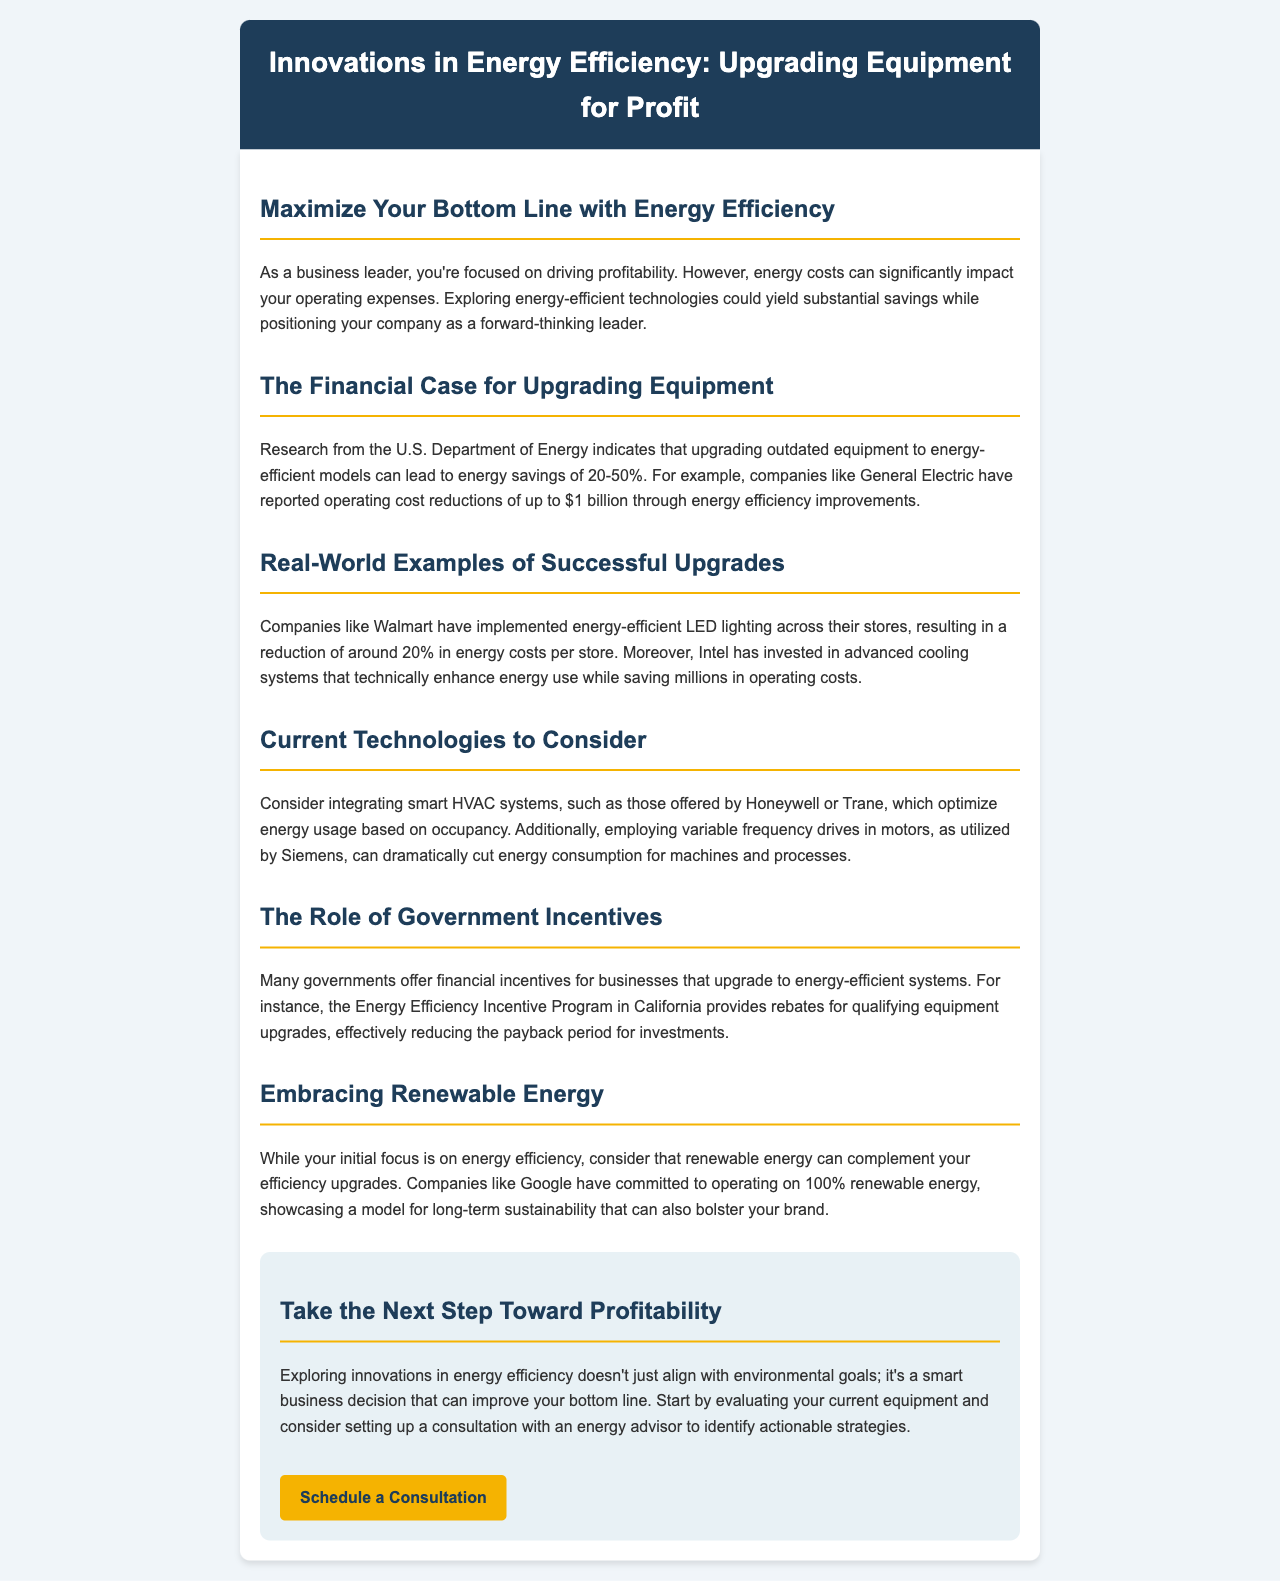What is the range of energy savings from upgrading outdated equipment? The document states that energy savings from upgrading outdated equipment can lead to savings of 20-50%.
Answer: 20-50% Which company reported operating cost reductions of up to $1 billion? The document mentions that General Electric reported these operating cost reductions.
Answer: General Electric What percentage reduction in energy costs did Walmart achieve with LED lighting? The document states that Walmart achieved around a 20% reduction in energy costs per store with LED lighting.
Answer: 20% What technologies are suggested for integrating smart HVAC systems? The document references Honeywell and Trane as companies offering these smart HVAC systems.
Answer: Honeywell or Trane Which program in California provides rebates for equipment upgrades? The document mentions the Energy Efficiency Incentive Program as the program providing rebates for qualifying upgrades.
Answer: Energy Efficiency Incentive Program Why is renewable energy mentioned in the context of energy efficiency? The document suggests that renewable energy can complement energy efficiency upgrades and provide long-term sustainability.
Answer: Complement energy efficiency upgrades What consultation is suggested to improve profitability? The document advises evaluating current equipment and considering a consultation with an energy advisor.
Answer: Consultation with an energy advisor What is a company that has committed to operating on 100% renewable energy? Google is mentioned in the document as a company that has made this commitment.
Answer: Google 